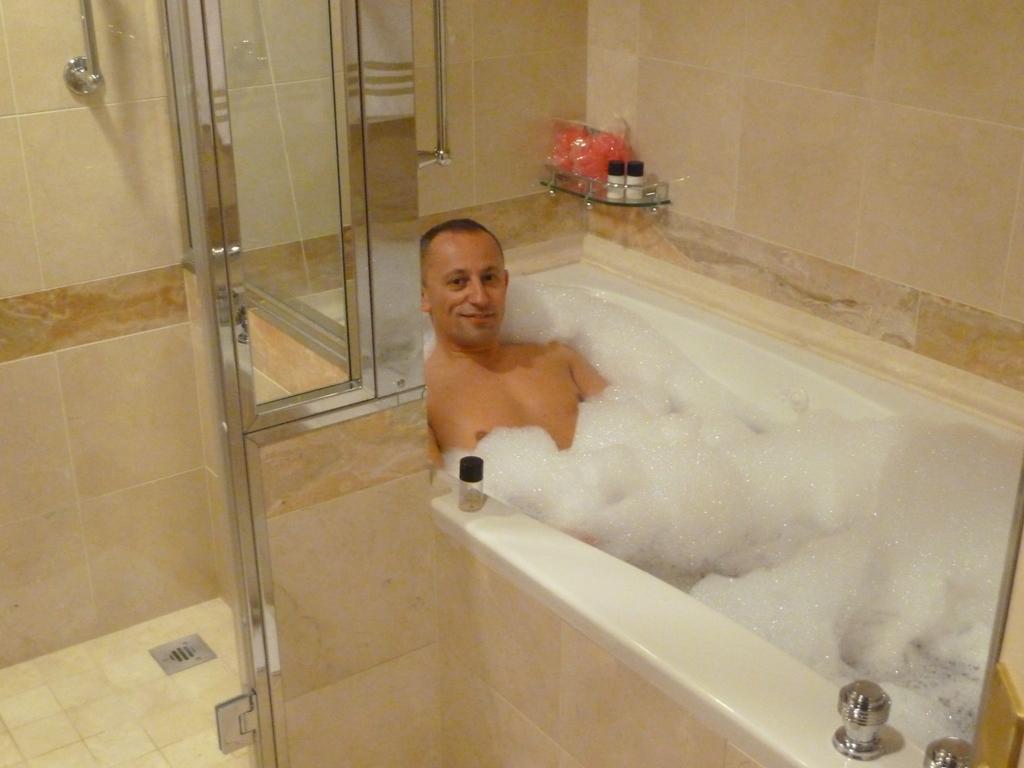How would you summarize this image in a sentence or two? In the foreground of this image, there is a glass door on the left. In the middle, there is a man in a bathtub, few objects in the bathroom stand and a wall. 